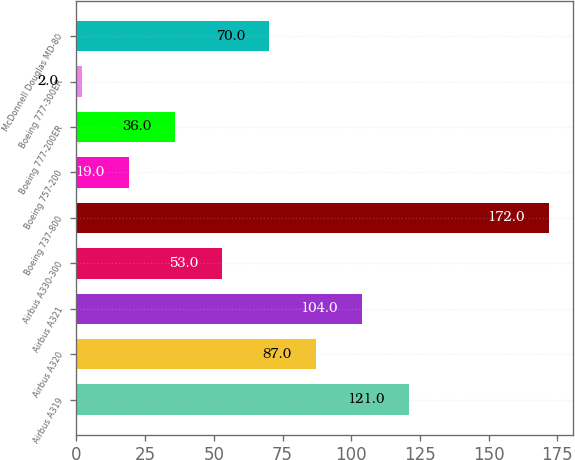Convert chart to OTSL. <chart><loc_0><loc_0><loc_500><loc_500><bar_chart><fcel>Airbus A319<fcel>Airbus A320<fcel>Airbus A321<fcel>Airbus A330-300<fcel>Boeing 737-800<fcel>Boeing 757-200<fcel>Boeing 777-200ER<fcel>Boeing 777-300ER<fcel>McDonnell Douglas MD-80<nl><fcel>121<fcel>87<fcel>104<fcel>53<fcel>172<fcel>19<fcel>36<fcel>2<fcel>70<nl></chart> 